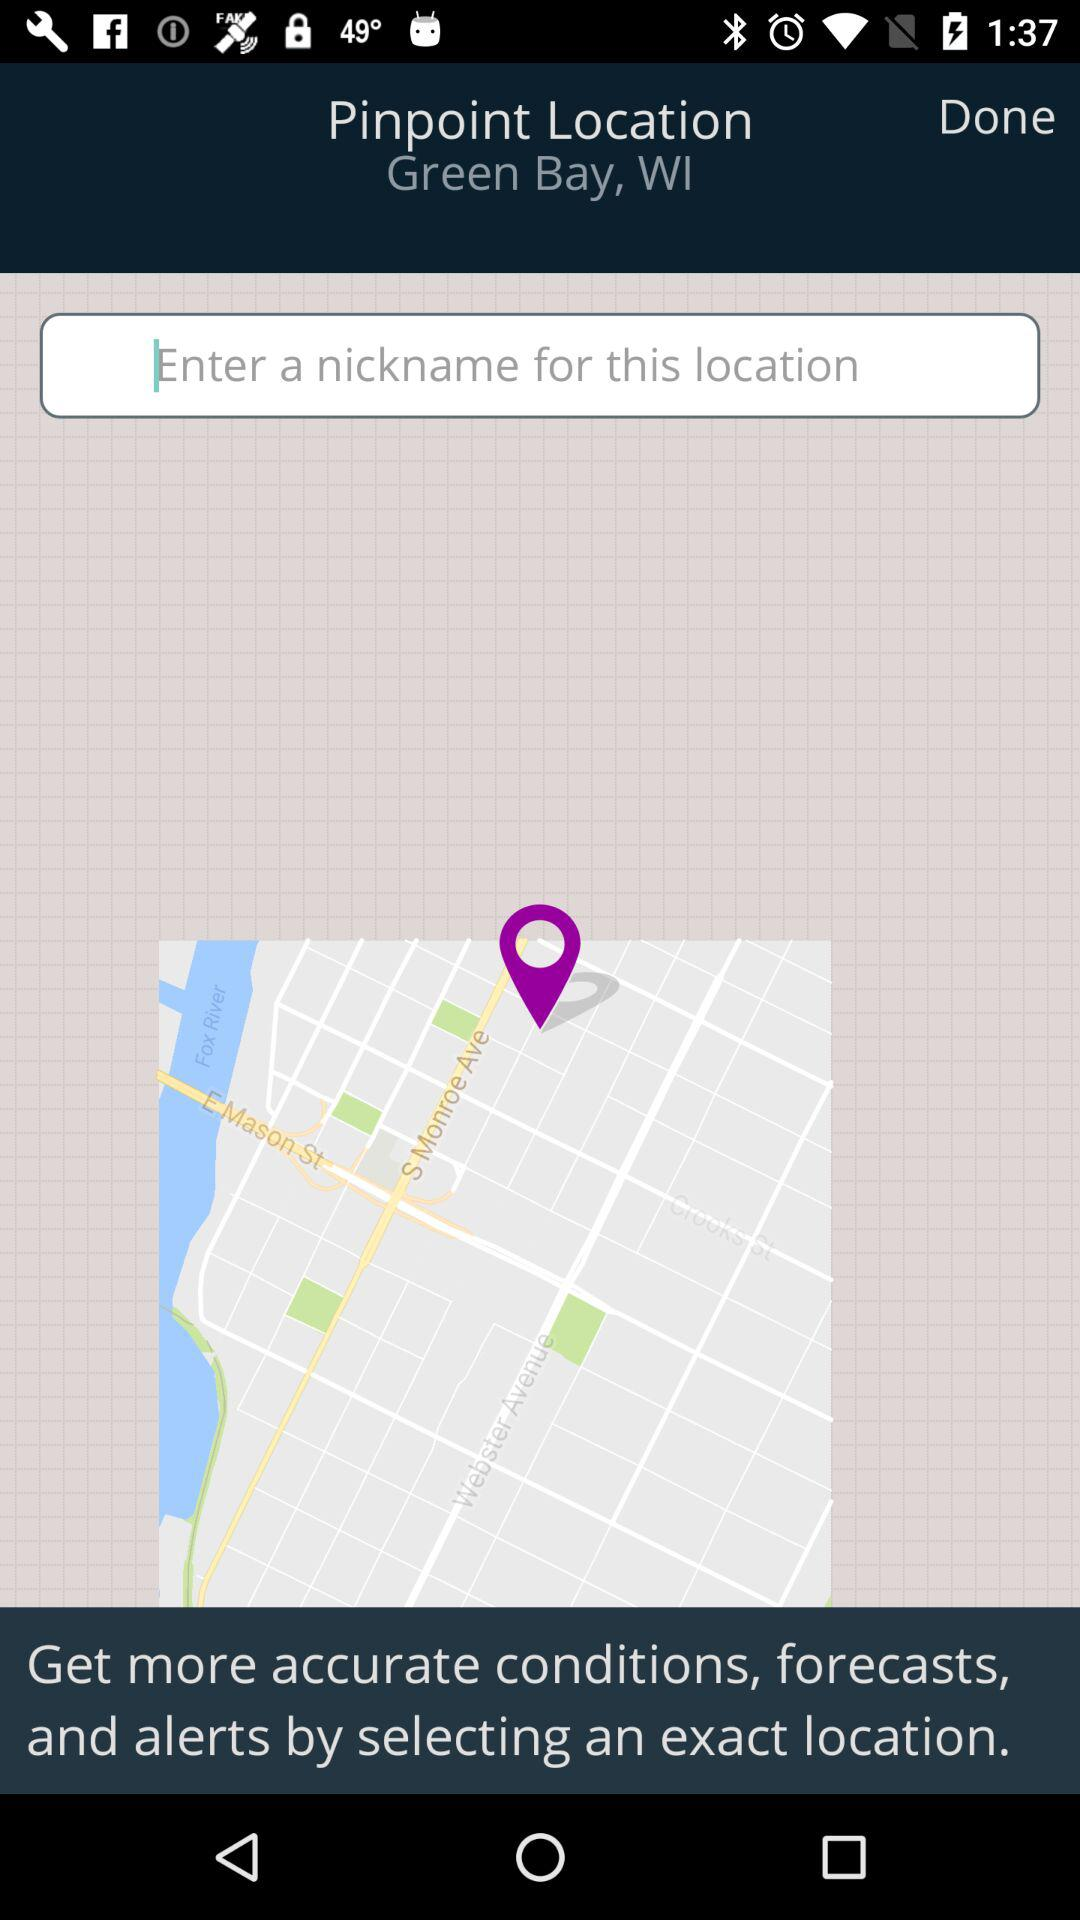What pin-point location is mentioned? The mentioned pin-point location is Green Bay, WI. 